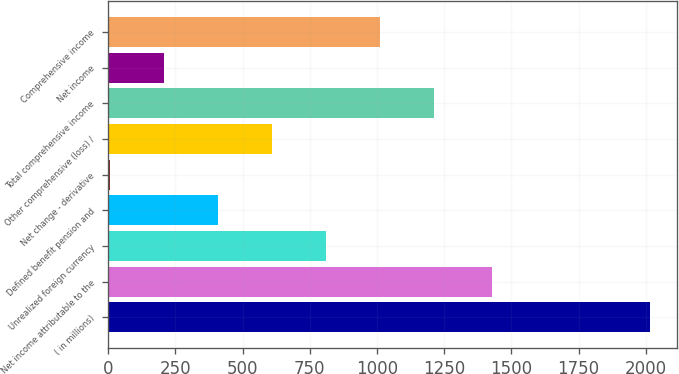Convert chart to OTSL. <chart><loc_0><loc_0><loc_500><loc_500><bar_chart><fcel>( in millions)<fcel>Net income attributable to the<fcel>Unrealized foreign currency<fcel>Defined benefit pension and<fcel>Net change - derivative<fcel>Other comprehensive (loss) /<fcel>Total comprehensive income<fcel>Net income<fcel>Comprehensive income<nl><fcel>2015<fcel>1427<fcel>809<fcel>407<fcel>5<fcel>608<fcel>1211<fcel>206<fcel>1010<nl></chart> 